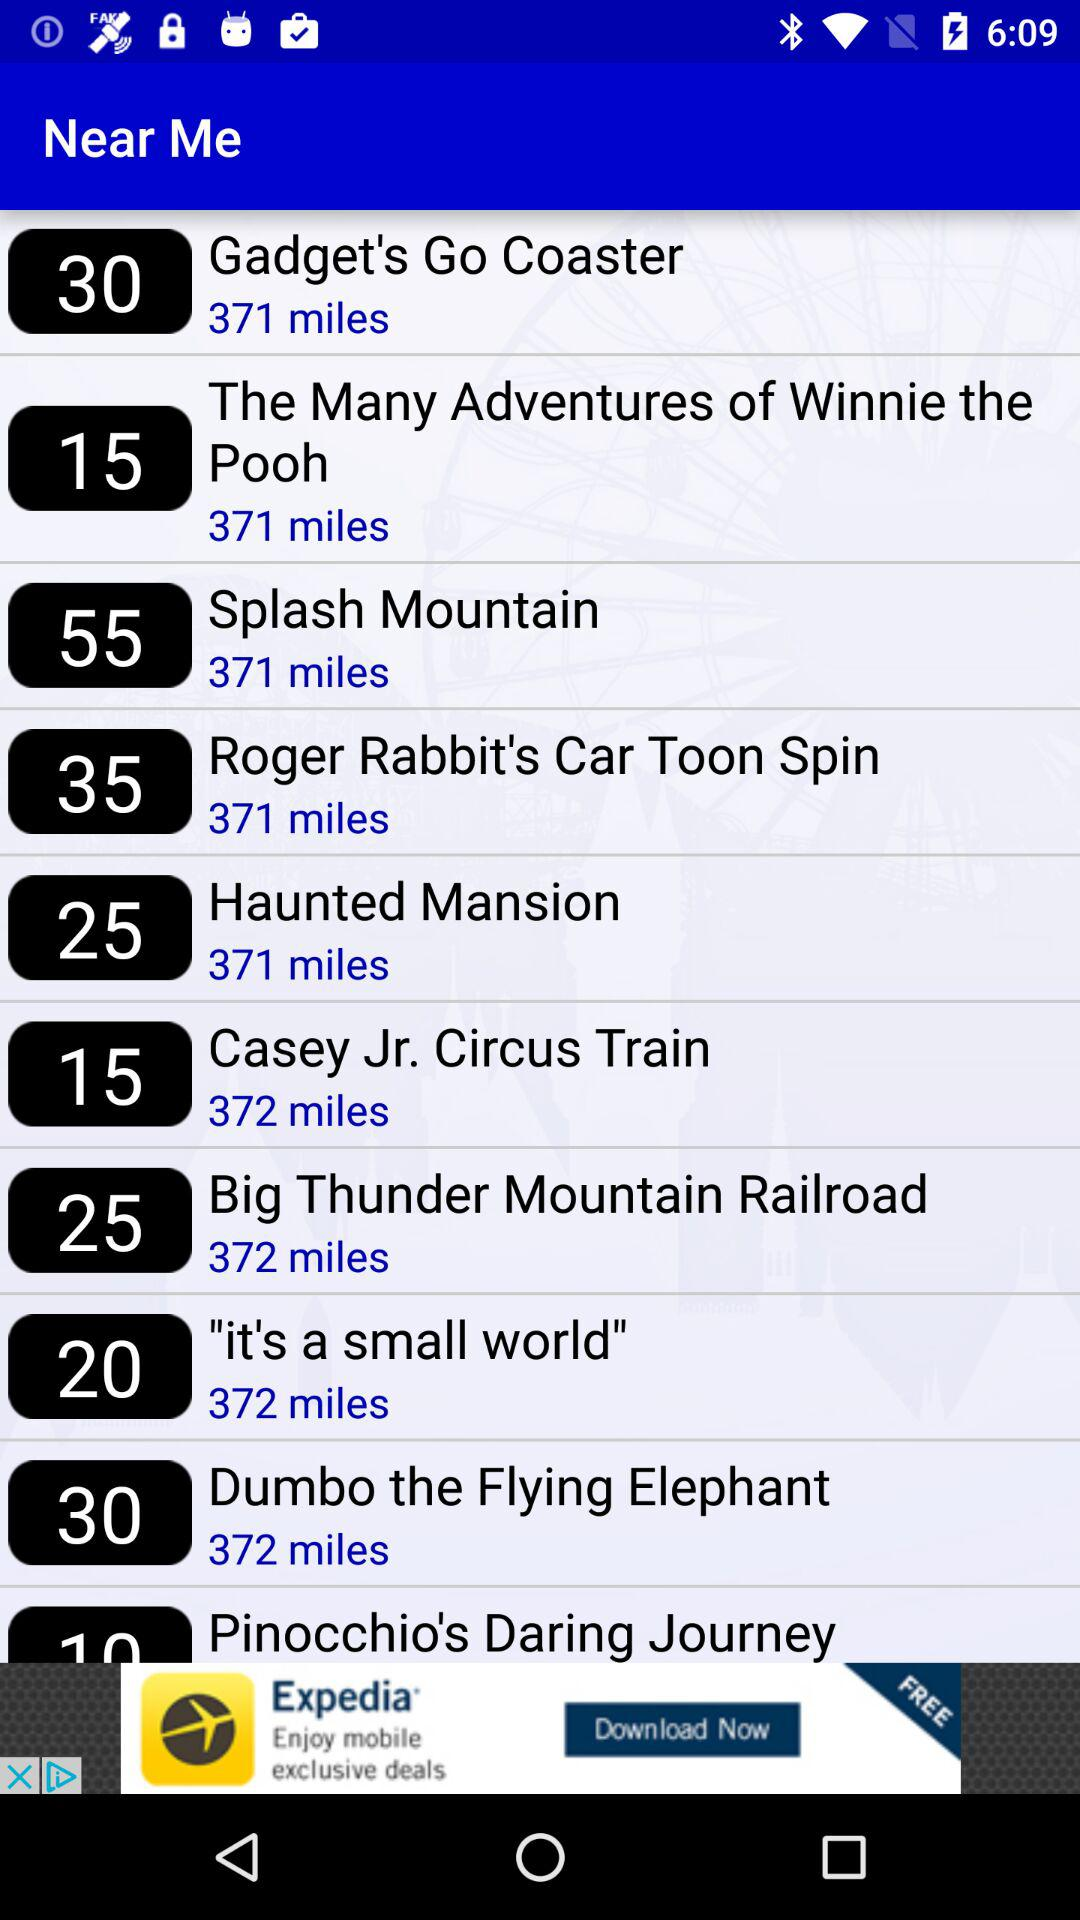What is the distance to the haunted mansion? The distance to the haunted mansion is 371 miles. 